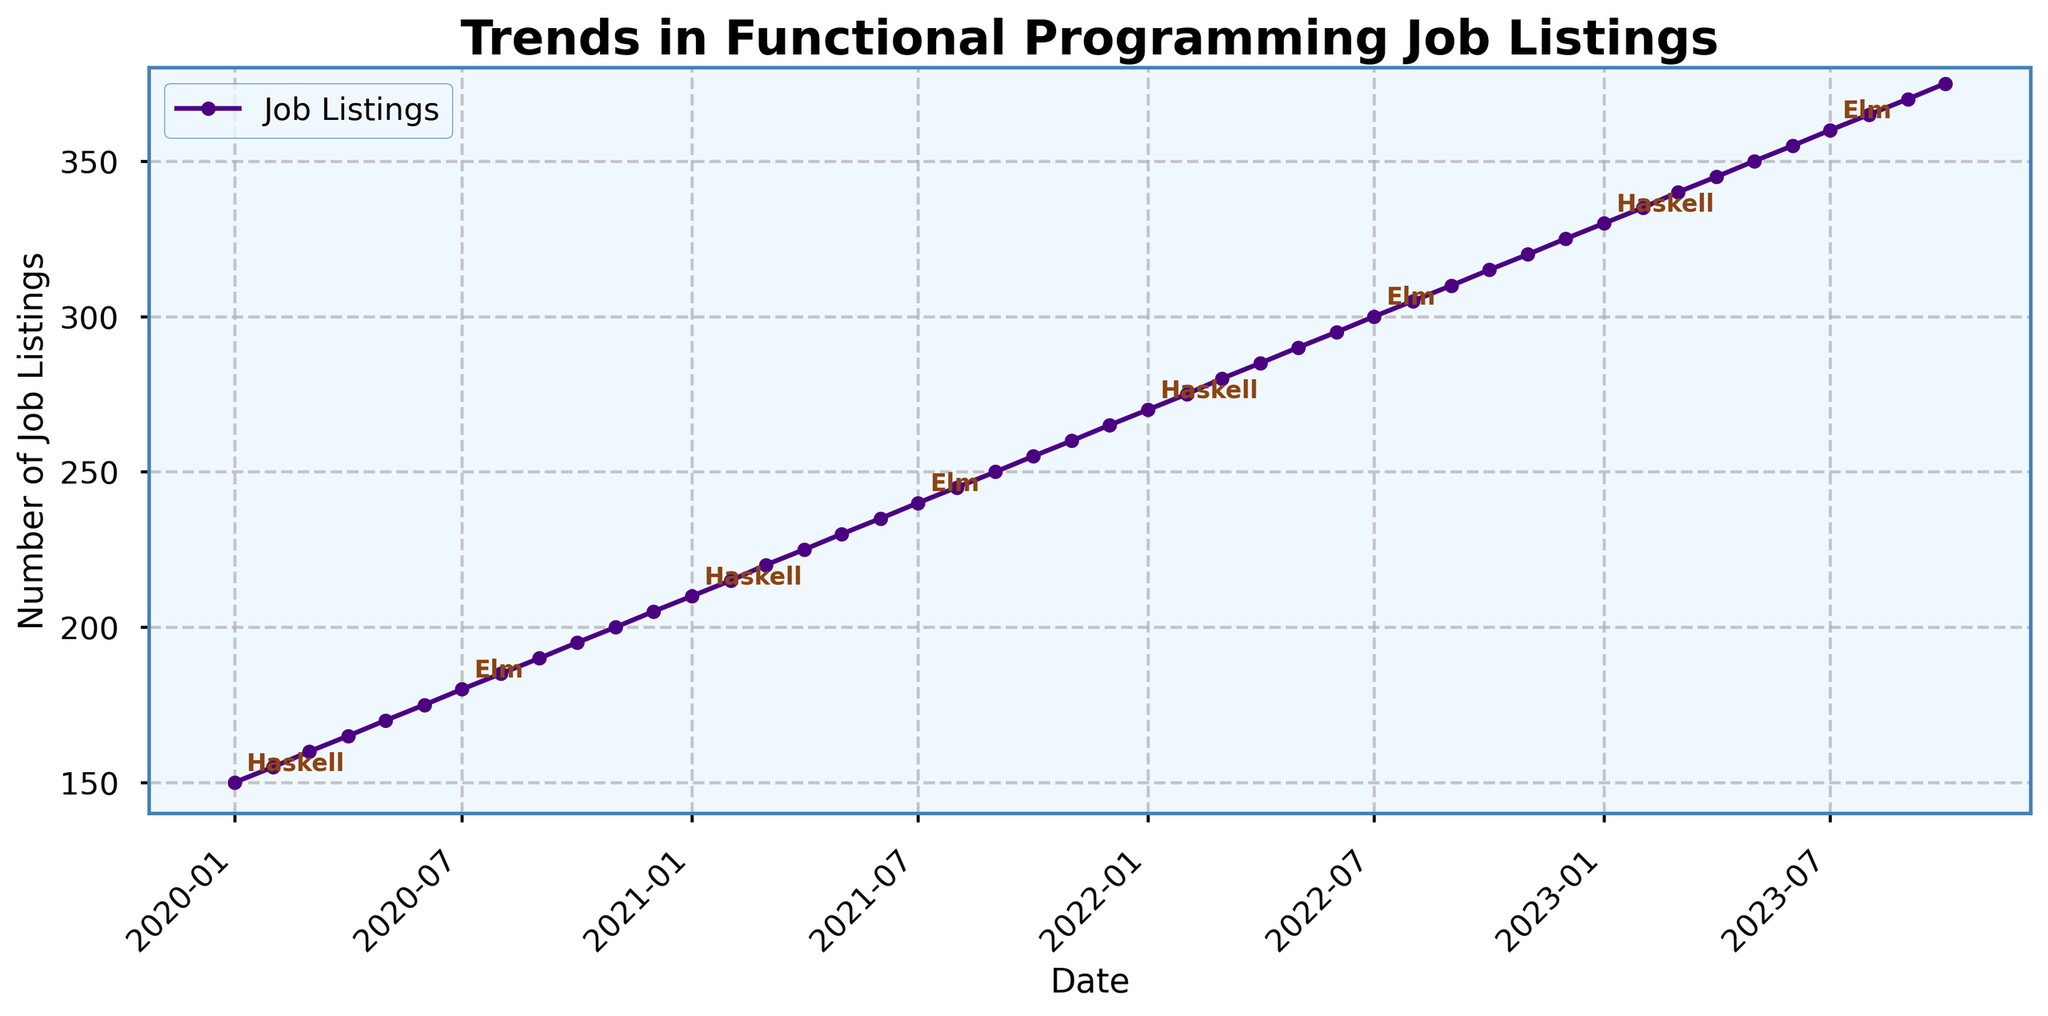What is the title of the plot? The title of the plot is usually located at the top of the graph. In this case, it reads "Trends in Functional Programming Job Listings" based on the provided code.
Answer: Trends in Functional Programming Job Listings What is the highest number of job listings shown and when was it recorded? To find the highest number of job listings, look at the peak of the plotted line. The highest point on the y-axis is 375, which is recorded in 2023-10.
Answer: 375 in 2023-10 How does the number of job listings change from January 2020 to December 2020? Observe the starting point in January 2020 and the endpoint in December 2020 on the x-axis. The number of job listings increases from 150 to 205. The change is 205 - 150 = 55.
Answer: Increased by 55 Which technology was most popular in January 2021? Look for the annotation near January 2021 on the x-axis. The technology associated with this date is Haskell.
Answer: Haskell What is the average number of job listings recorded in 2020? Find the values for each month in 2020, and calculate the average. The numbers are 150, 155, 160, 165, 170, 175, 180, 185, 190, 195, 200, and 205. Sum these values (2180) and divide by 12.
Answer: 181.67 What technology became popular after Elm and when did this change occur? Look at the order of annotations on the plot. After Elm, the next technology is Clojure. The change occurs after August 2020.
Answer: Clojure in September 2020 How many times is Elixir mentioned in the entire time period shown? Count the instances of the annotations labeled "Elixir" on the plot. Elixir is mentioned in May 2020, June 2020, May 2021, June 2021, May 2022, June 2022, May 2023, and June 2023.
Answer: 8 times During which six-month period did the number of job listings increase the most? Divide the time frame into six-month periods and check the change in job listings for each. The highest increase is from July 2023 (360) to October 2023 (375), an increase of 15.
Answer: July 2023 to October 2023 What's the trend for the number of job listings from 2020 to 2023? Observe the overall line from start (2020) to end (2023). The number of job listings shows an upward trend.
Answer: Upward trend 